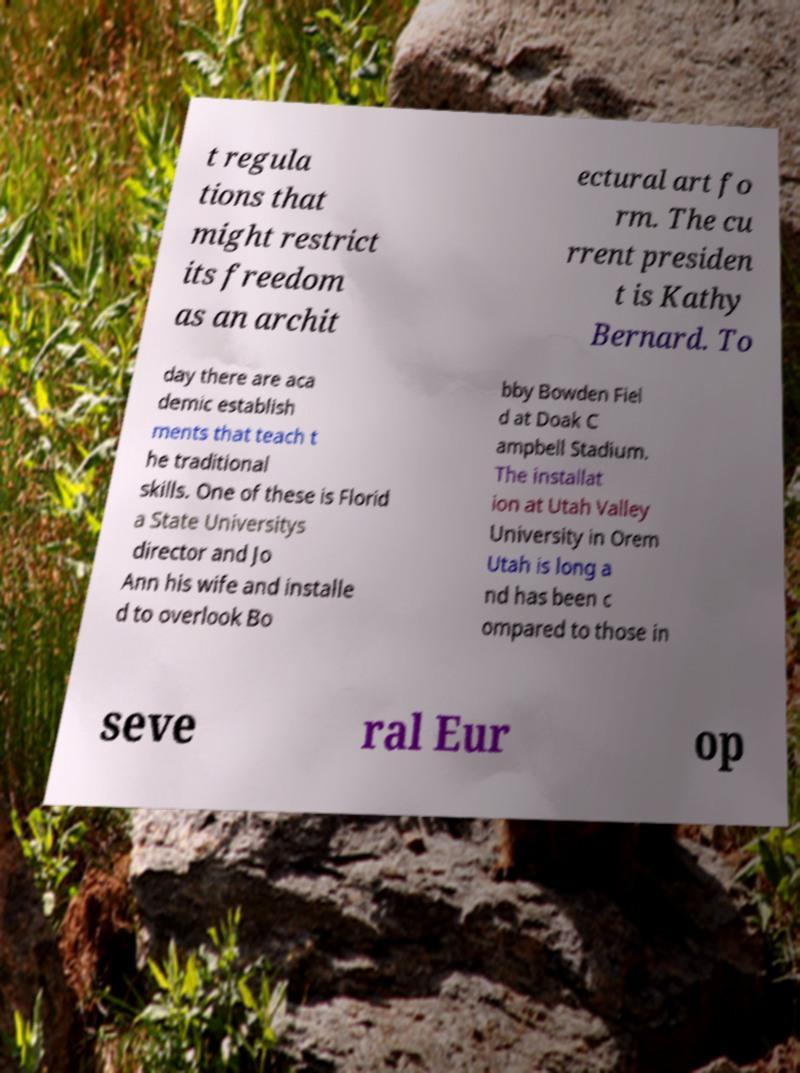Please identify and transcribe the text found in this image. t regula tions that might restrict its freedom as an archit ectural art fo rm. The cu rrent presiden t is Kathy Bernard. To day there are aca demic establish ments that teach t he traditional skills. One of these is Florid a State Universitys director and Jo Ann his wife and installe d to overlook Bo bby Bowden Fiel d at Doak C ampbell Stadium. The installat ion at Utah Valley University in Orem Utah is long a nd has been c ompared to those in seve ral Eur op 